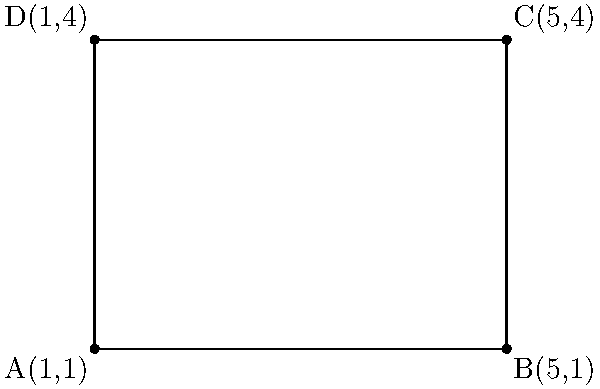Given the coordinates of the vertices of a rectangle ABCD as A(1,1), B(5,1), C(5,4), and D(1,4), calculate the area of the rectangle. To calculate the area of a rectangle, we need to find its length and width. We can do this using the coordinates of the vertices:

1. Calculate the length (l):
   Length is the distance between points A and B (or D and C).
   $l = |x_B - x_A| = |5 - 1| = 4$

2. Calculate the width (w):
   Width is the distance between points A and D (or B and C).
   $w = |y_D - y_A| = |4 - 1| = 3$

3. Calculate the area:
   The formula for the area of a rectangle is $A = l \times w$
   $A = 4 \times 3 = 12$

Therefore, the area of the rectangle ABCD is 12 square units.
Answer: 12 square units 